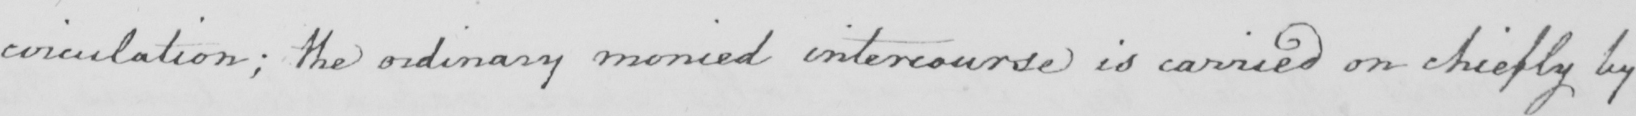What does this handwritten line say? circulation ; the ordinary monied intercourse is carried on chiefly by 